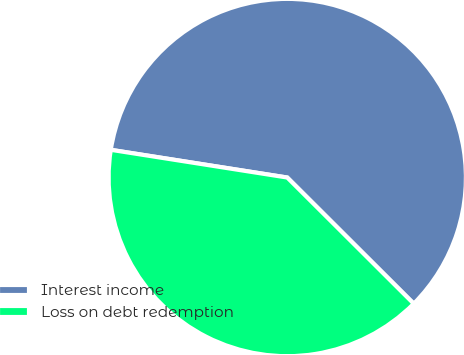Convert chart to OTSL. <chart><loc_0><loc_0><loc_500><loc_500><pie_chart><fcel>Interest income<fcel>Loss on debt redemption<nl><fcel>60.0%<fcel>40.0%<nl></chart> 